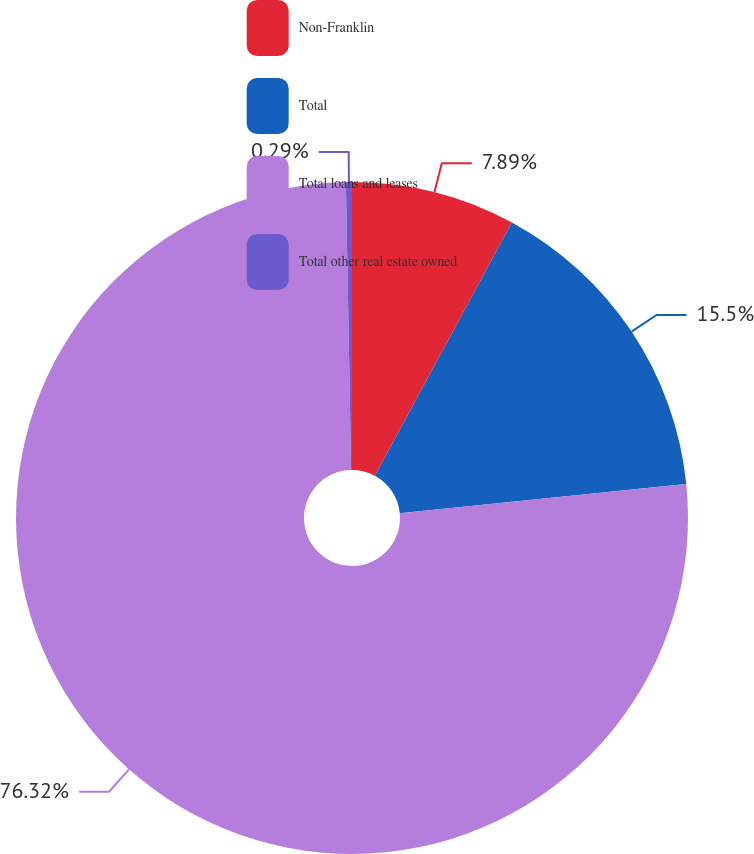Convert chart to OTSL. <chart><loc_0><loc_0><loc_500><loc_500><pie_chart><fcel>Non-Franklin<fcel>Total<fcel>Total loans and leases<fcel>Total other real estate owned<nl><fcel>7.89%<fcel>15.5%<fcel>76.32%<fcel>0.29%<nl></chart> 